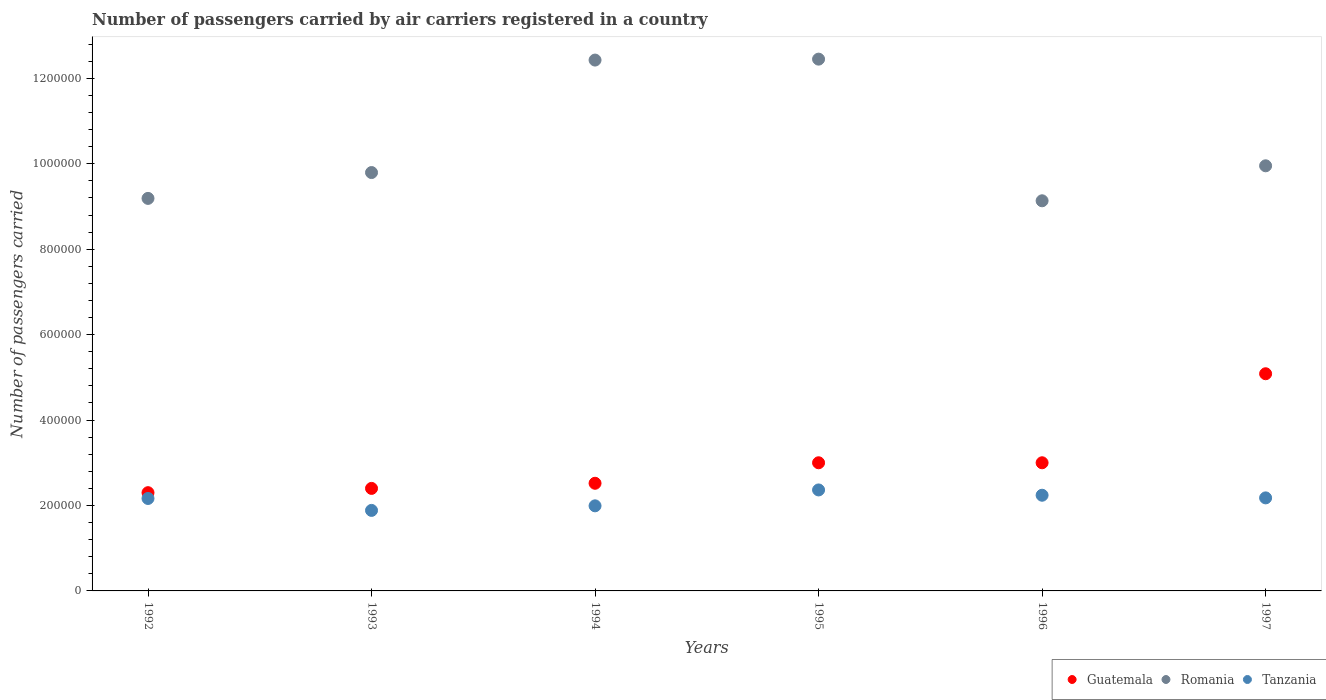How many different coloured dotlines are there?
Keep it short and to the point. 3. What is the number of passengers carried by air carriers in Tanzania in 1993?
Your response must be concise. 1.88e+05. Across all years, what is the maximum number of passengers carried by air carriers in Guatemala?
Your answer should be very brief. 5.08e+05. In which year was the number of passengers carried by air carriers in Romania maximum?
Your response must be concise. 1995. In which year was the number of passengers carried by air carriers in Romania minimum?
Offer a very short reply. 1996. What is the total number of passengers carried by air carriers in Romania in the graph?
Offer a terse response. 6.29e+06. What is the difference between the number of passengers carried by air carriers in Tanzania in 1992 and that in 1993?
Your response must be concise. 2.79e+04. What is the difference between the number of passengers carried by air carriers in Guatemala in 1992 and the number of passengers carried by air carriers in Tanzania in 1997?
Your response must be concise. 1.22e+04. What is the average number of passengers carried by air carriers in Guatemala per year?
Ensure brevity in your answer.  3.05e+05. In the year 1994, what is the difference between the number of passengers carried by air carriers in Romania and number of passengers carried by air carriers in Guatemala?
Ensure brevity in your answer.  9.91e+05. What is the ratio of the number of passengers carried by air carriers in Guatemala in 1995 to that in 1997?
Keep it short and to the point. 0.59. Is the difference between the number of passengers carried by air carriers in Romania in 1994 and 1995 greater than the difference between the number of passengers carried by air carriers in Guatemala in 1994 and 1995?
Keep it short and to the point. Yes. What is the difference between the highest and the second highest number of passengers carried by air carriers in Romania?
Offer a terse response. 2200. What is the difference between the highest and the lowest number of passengers carried by air carriers in Romania?
Offer a very short reply. 3.32e+05. In how many years, is the number of passengers carried by air carriers in Guatemala greater than the average number of passengers carried by air carriers in Guatemala taken over all years?
Offer a very short reply. 1. Is the sum of the number of passengers carried by air carriers in Guatemala in 1996 and 1997 greater than the maximum number of passengers carried by air carriers in Romania across all years?
Your response must be concise. No. Is the number of passengers carried by air carriers in Tanzania strictly greater than the number of passengers carried by air carriers in Romania over the years?
Provide a succinct answer. No. How many dotlines are there?
Your answer should be very brief. 3. What is the difference between two consecutive major ticks on the Y-axis?
Keep it short and to the point. 2.00e+05. Are the values on the major ticks of Y-axis written in scientific E-notation?
Your answer should be very brief. No. Does the graph contain any zero values?
Your response must be concise. No. Does the graph contain grids?
Your answer should be very brief. No. Where does the legend appear in the graph?
Your answer should be compact. Bottom right. How many legend labels are there?
Your answer should be very brief. 3. How are the legend labels stacked?
Your response must be concise. Horizontal. What is the title of the graph?
Your answer should be compact. Number of passengers carried by air carriers registered in a country. Does "South Sudan" appear as one of the legend labels in the graph?
Provide a succinct answer. No. What is the label or title of the X-axis?
Keep it short and to the point. Years. What is the label or title of the Y-axis?
Provide a short and direct response. Number of passengers carried. What is the Number of passengers carried of Guatemala in 1992?
Offer a terse response. 2.30e+05. What is the Number of passengers carried in Romania in 1992?
Ensure brevity in your answer.  9.19e+05. What is the Number of passengers carried in Tanzania in 1992?
Make the answer very short. 2.16e+05. What is the Number of passengers carried of Guatemala in 1993?
Offer a terse response. 2.40e+05. What is the Number of passengers carried of Romania in 1993?
Offer a very short reply. 9.79e+05. What is the Number of passengers carried of Tanzania in 1993?
Offer a terse response. 1.88e+05. What is the Number of passengers carried in Guatemala in 1994?
Provide a short and direct response. 2.52e+05. What is the Number of passengers carried in Romania in 1994?
Provide a short and direct response. 1.24e+06. What is the Number of passengers carried in Tanzania in 1994?
Give a very brief answer. 1.99e+05. What is the Number of passengers carried in Guatemala in 1995?
Your answer should be very brief. 3.00e+05. What is the Number of passengers carried in Romania in 1995?
Ensure brevity in your answer.  1.24e+06. What is the Number of passengers carried in Tanzania in 1995?
Make the answer very short. 2.36e+05. What is the Number of passengers carried of Romania in 1996?
Give a very brief answer. 9.13e+05. What is the Number of passengers carried in Tanzania in 1996?
Provide a succinct answer. 2.24e+05. What is the Number of passengers carried in Guatemala in 1997?
Your answer should be very brief. 5.08e+05. What is the Number of passengers carried in Romania in 1997?
Offer a terse response. 9.95e+05. What is the Number of passengers carried of Tanzania in 1997?
Make the answer very short. 2.18e+05. Across all years, what is the maximum Number of passengers carried in Guatemala?
Give a very brief answer. 5.08e+05. Across all years, what is the maximum Number of passengers carried of Romania?
Provide a succinct answer. 1.24e+06. Across all years, what is the maximum Number of passengers carried of Tanzania?
Your answer should be very brief. 2.36e+05. Across all years, what is the minimum Number of passengers carried in Guatemala?
Your answer should be compact. 2.30e+05. Across all years, what is the minimum Number of passengers carried of Romania?
Keep it short and to the point. 9.13e+05. Across all years, what is the minimum Number of passengers carried in Tanzania?
Offer a very short reply. 1.88e+05. What is the total Number of passengers carried in Guatemala in the graph?
Your answer should be very brief. 1.83e+06. What is the total Number of passengers carried of Romania in the graph?
Your answer should be compact. 6.29e+06. What is the total Number of passengers carried in Tanzania in the graph?
Provide a short and direct response. 1.28e+06. What is the difference between the Number of passengers carried of Romania in 1992 and that in 1993?
Offer a very short reply. -6.05e+04. What is the difference between the Number of passengers carried in Tanzania in 1992 and that in 1993?
Provide a short and direct response. 2.79e+04. What is the difference between the Number of passengers carried in Guatemala in 1992 and that in 1994?
Provide a short and direct response. -2.20e+04. What is the difference between the Number of passengers carried of Romania in 1992 and that in 1994?
Make the answer very short. -3.24e+05. What is the difference between the Number of passengers carried of Tanzania in 1992 and that in 1994?
Provide a short and direct response. 1.72e+04. What is the difference between the Number of passengers carried of Guatemala in 1992 and that in 1995?
Provide a short and direct response. -7.00e+04. What is the difference between the Number of passengers carried of Romania in 1992 and that in 1995?
Provide a short and direct response. -3.26e+05. What is the difference between the Number of passengers carried of Guatemala in 1992 and that in 1996?
Your response must be concise. -7.00e+04. What is the difference between the Number of passengers carried of Romania in 1992 and that in 1996?
Offer a very short reply. 5600. What is the difference between the Number of passengers carried in Tanzania in 1992 and that in 1996?
Provide a succinct answer. -7600. What is the difference between the Number of passengers carried of Guatemala in 1992 and that in 1997?
Provide a short and direct response. -2.78e+05. What is the difference between the Number of passengers carried of Romania in 1992 and that in 1997?
Provide a short and direct response. -7.63e+04. What is the difference between the Number of passengers carried of Tanzania in 1992 and that in 1997?
Provide a succinct answer. -1400. What is the difference between the Number of passengers carried in Guatemala in 1993 and that in 1994?
Give a very brief answer. -1.20e+04. What is the difference between the Number of passengers carried in Romania in 1993 and that in 1994?
Your answer should be compact. -2.63e+05. What is the difference between the Number of passengers carried of Tanzania in 1993 and that in 1994?
Your response must be concise. -1.07e+04. What is the difference between the Number of passengers carried of Guatemala in 1993 and that in 1995?
Make the answer very short. -6.00e+04. What is the difference between the Number of passengers carried in Romania in 1993 and that in 1995?
Make the answer very short. -2.66e+05. What is the difference between the Number of passengers carried of Tanzania in 1993 and that in 1995?
Offer a very short reply. -4.79e+04. What is the difference between the Number of passengers carried in Romania in 1993 and that in 1996?
Provide a succinct answer. 6.61e+04. What is the difference between the Number of passengers carried of Tanzania in 1993 and that in 1996?
Offer a very short reply. -3.55e+04. What is the difference between the Number of passengers carried in Guatemala in 1993 and that in 1997?
Your answer should be compact. -2.68e+05. What is the difference between the Number of passengers carried in Romania in 1993 and that in 1997?
Provide a short and direct response. -1.58e+04. What is the difference between the Number of passengers carried of Tanzania in 1993 and that in 1997?
Offer a very short reply. -2.93e+04. What is the difference between the Number of passengers carried of Guatemala in 1994 and that in 1995?
Give a very brief answer. -4.80e+04. What is the difference between the Number of passengers carried of Romania in 1994 and that in 1995?
Provide a succinct answer. -2200. What is the difference between the Number of passengers carried of Tanzania in 1994 and that in 1995?
Provide a short and direct response. -3.72e+04. What is the difference between the Number of passengers carried in Guatemala in 1994 and that in 1996?
Your answer should be compact. -4.80e+04. What is the difference between the Number of passengers carried of Romania in 1994 and that in 1996?
Offer a terse response. 3.29e+05. What is the difference between the Number of passengers carried of Tanzania in 1994 and that in 1996?
Offer a very short reply. -2.48e+04. What is the difference between the Number of passengers carried in Guatemala in 1994 and that in 1997?
Offer a very short reply. -2.56e+05. What is the difference between the Number of passengers carried of Romania in 1994 and that in 1997?
Provide a succinct answer. 2.48e+05. What is the difference between the Number of passengers carried of Tanzania in 1994 and that in 1997?
Offer a terse response. -1.86e+04. What is the difference between the Number of passengers carried of Guatemala in 1995 and that in 1996?
Ensure brevity in your answer.  0. What is the difference between the Number of passengers carried in Romania in 1995 and that in 1996?
Your response must be concise. 3.32e+05. What is the difference between the Number of passengers carried of Tanzania in 1995 and that in 1996?
Your answer should be compact. 1.24e+04. What is the difference between the Number of passengers carried of Guatemala in 1995 and that in 1997?
Make the answer very short. -2.08e+05. What is the difference between the Number of passengers carried in Romania in 1995 and that in 1997?
Keep it short and to the point. 2.50e+05. What is the difference between the Number of passengers carried in Tanzania in 1995 and that in 1997?
Offer a very short reply. 1.86e+04. What is the difference between the Number of passengers carried in Guatemala in 1996 and that in 1997?
Your answer should be very brief. -2.08e+05. What is the difference between the Number of passengers carried in Romania in 1996 and that in 1997?
Your answer should be very brief. -8.19e+04. What is the difference between the Number of passengers carried in Tanzania in 1996 and that in 1997?
Your answer should be very brief. 6200. What is the difference between the Number of passengers carried of Guatemala in 1992 and the Number of passengers carried of Romania in 1993?
Your answer should be compact. -7.49e+05. What is the difference between the Number of passengers carried in Guatemala in 1992 and the Number of passengers carried in Tanzania in 1993?
Your answer should be very brief. 4.15e+04. What is the difference between the Number of passengers carried in Romania in 1992 and the Number of passengers carried in Tanzania in 1993?
Provide a succinct answer. 7.30e+05. What is the difference between the Number of passengers carried of Guatemala in 1992 and the Number of passengers carried of Romania in 1994?
Give a very brief answer. -1.01e+06. What is the difference between the Number of passengers carried of Guatemala in 1992 and the Number of passengers carried of Tanzania in 1994?
Your answer should be very brief. 3.08e+04. What is the difference between the Number of passengers carried in Romania in 1992 and the Number of passengers carried in Tanzania in 1994?
Offer a terse response. 7.20e+05. What is the difference between the Number of passengers carried in Guatemala in 1992 and the Number of passengers carried in Romania in 1995?
Offer a very short reply. -1.01e+06. What is the difference between the Number of passengers carried in Guatemala in 1992 and the Number of passengers carried in Tanzania in 1995?
Offer a very short reply. -6400. What is the difference between the Number of passengers carried of Romania in 1992 and the Number of passengers carried of Tanzania in 1995?
Give a very brief answer. 6.82e+05. What is the difference between the Number of passengers carried of Guatemala in 1992 and the Number of passengers carried of Romania in 1996?
Your answer should be compact. -6.83e+05. What is the difference between the Number of passengers carried in Guatemala in 1992 and the Number of passengers carried in Tanzania in 1996?
Provide a succinct answer. 6000. What is the difference between the Number of passengers carried in Romania in 1992 and the Number of passengers carried in Tanzania in 1996?
Your answer should be very brief. 6.95e+05. What is the difference between the Number of passengers carried in Guatemala in 1992 and the Number of passengers carried in Romania in 1997?
Give a very brief answer. -7.65e+05. What is the difference between the Number of passengers carried in Guatemala in 1992 and the Number of passengers carried in Tanzania in 1997?
Ensure brevity in your answer.  1.22e+04. What is the difference between the Number of passengers carried of Romania in 1992 and the Number of passengers carried of Tanzania in 1997?
Your answer should be compact. 7.01e+05. What is the difference between the Number of passengers carried in Guatemala in 1993 and the Number of passengers carried in Romania in 1994?
Your answer should be very brief. -1.00e+06. What is the difference between the Number of passengers carried of Guatemala in 1993 and the Number of passengers carried of Tanzania in 1994?
Offer a very short reply. 4.08e+04. What is the difference between the Number of passengers carried of Romania in 1993 and the Number of passengers carried of Tanzania in 1994?
Your answer should be very brief. 7.80e+05. What is the difference between the Number of passengers carried of Guatemala in 1993 and the Number of passengers carried of Romania in 1995?
Provide a succinct answer. -1.00e+06. What is the difference between the Number of passengers carried in Guatemala in 1993 and the Number of passengers carried in Tanzania in 1995?
Offer a very short reply. 3600. What is the difference between the Number of passengers carried in Romania in 1993 and the Number of passengers carried in Tanzania in 1995?
Your response must be concise. 7.43e+05. What is the difference between the Number of passengers carried of Guatemala in 1993 and the Number of passengers carried of Romania in 1996?
Give a very brief answer. -6.73e+05. What is the difference between the Number of passengers carried of Guatemala in 1993 and the Number of passengers carried of Tanzania in 1996?
Keep it short and to the point. 1.60e+04. What is the difference between the Number of passengers carried in Romania in 1993 and the Number of passengers carried in Tanzania in 1996?
Give a very brief answer. 7.55e+05. What is the difference between the Number of passengers carried of Guatemala in 1993 and the Number of passengers carried of Romania in 1997?
Your answer should be compact. -7.55e+05. What is the difference between the Number of passengers carried in Guatemala in 1993 and the Number of passengers carried in Tanzania in 1997?
Offer a very short reply. 2.22e+04. What is the difference between the Number of passengers carried in Romania in 1993 and the Number of passengers carried in Tanzania in 1997?
Your answer should be very brief. 7.62e+05. What is the difference between the Number of passengers carried in Guatemala in 1994 and the Number of passengers carried in Romania in 1995?
Provide a succinct answer. -9.93e+05. What is the difference between the Number of passengers carried in Guatemala in 1994 and the Number of passengers carried in Tanzania in 1995?
Ensure brevity in your answer.  1.56e+04. What is the difference between the Number of passengers carried in Romania in 1994 and the Number of passengers carried in Tanzania in 1995?
Offer a terse response. 1.01e+06. What is the difference between the Number of passengers carried of Guatemala in 1994 and the Number of passengers carried of Romania in 1996?
Keep it short and to the point. -6.61e+05. What is the difference between the Number of passengers carried of Guatemala in 1994 and the Number of passengers carried of Tanzania in 1996?
Your response must be concise. 2.80e+04. What is the difference between the Number of passengers carried in Romania in 1994 and the Number of passengers carried in Tanzania in 1996?
Ensure brevity in your answer.  1.02e+06. What is the difference between the Number of passengers carried of Guatemala in 1994 and the Number of passengers carried of Romania in 1997?
Provide a short and direct response. -7.43e+05. What is the difference between the Number of passengers carried in Guatemala in 1994 and the Number of passengers carried in Tanzania in 1997?
Provide a short and direct response. 3.42e+04. What is the difference between the Number of passengers carried in Romania in 1994 and the Number of passengers carried in Tanzania in 1997?
Make the answer very short. 1.02e+06. What is the difference between the Number of passengers carried in Guatemala in 1995 and the Number of passengers carried in Romania in 1996?
Make the answer very short. -6.13e+05. What is the difference between the Number of passengers carried of Guatemala in 1995 and the Number of passengers carried of Tanzania in 1996?
Provide a short and direct response. 7.60e+04. What is the difference between the Number of passengers carried in Romania in 1995 and the Number of passengers carried in Tanzania in 1996?
Your answer should be very brief. 1.02e+06. What is the difference between the Number of passengers carried of Guatemala in 1995 and the Number of passengers carried of Romania in 1997?
Ensure brevity in your answer.  -6.95e+05. What is the difference between the Number of passengers carried of Guatemala in 1995 and the Number of passengers carried of Tanzania in 1997?
Give a very brief answer. 8.22e+04. What is the difference between the Number of passengers carried of Romania in 1995 and the Number of passengers carried of Tanzania in 1997?
Ensure brevity in your answer.  1.03e+06. What is the difference between the Number of passengers carried of Guatemala in 1996 and the Number of passengers carried of Romania in 1997?
Offer a very short reply. -6.95e+05. What is the difference between the Number of passengers carried in Guatemala in 1996 and the Number of passengers carried in Tanzania in 1997?
Your answer should be very brief. 8.22e+04. What is the difference between the Number of passengers carried in Romania in 1996 and the Number of passengers carried in Tanzania in 1997?
Provide a short and direct response. 6.96e+05. What is the average Number of passengers carried in Guatemala per year?
Give a very brief answer. 3.05e+05. What is the average Number of passengers carried in Romania per year?
Keep it short and to the point. 1.05e+06. What is the average Number of passengers carried of Tanzania per year?
Give a very brief answer. 2.14e+05. In the year 1992, what is the difference between the Number of passengers carried in Guatemala and Number of passengers carried in Romania?
Provide a succinct answer. -6.89e+05. In the year 1992, what is the difference between the Number of passengers carried in Guatemala and Number of passengers carried in Tanzania?
Provide a succinct answer. 1.36e+04. In the year 1992, what is the difference between the Number of passengers carried of Romania and Number of passengers carried of Tanzania?
Give a very brief answer. 7.02e+05. In the year 1993, what is the difference between the Number of passengers carried of Guatemala and Number of passengers carried of Romania?
Keep it short and to the point. -7.39e+05. In the year 1993, what is the difference between the Number of passengers carried of Guatemala and Number of passengers carried of Tanzania?
Provide a short and direct response. 5.15e+04. In the year 1993, what is the difference between the Number of passengers carried of Romania and Number of passengers carried of Tanzania?
Offer a terse response. 7.91e+05. In the year 1994, what is the difference between the Number of passengers carried of Guatemala and Number of passengers carried of Romania?
Offer a very short reply. -9.91e+05. In the year 1994, what is the difference between the Number of passengers carried in Guatemala and Number of passengers carried in Tanzania?
Offer a very short reply. 5.28e+04. In the year 1994, what is the difference between the Number of passengers carried in Romania and Number of passengers carried in Tanzania?
Your response must be concise. 1.04e+06. In the year 1995, what is the difference between the Number of passengers carried of Guatemala and Number of passengers carried of Romania?
Offer a terse response. -9.45e+05. In the year 1995, what is the difference between the Number of passengers carried of Guatemala and Number of passengers carried of Tanzania?
Provide a succinct answer. 6.36e+04. In the year 1995, what is the difference between the Number of passengers carried of Romania and Number of passengers carried of Tanzania?
Your response must be concise. 1.01e+06. In the year 1996, what is the difference between the Number of passengers carried in Guatemala and Number of passengers carried in Romania?
Ensure brevity in your answer.  -6.13e+05. In the year 1996, what is the difference between the Number of passengers carried of Guatemala and Number of passengers carried of Tanzania?
Make the answer very short. 7.60e+04. In the year 1996, what is the difference between the Number of passengers carried in Romania and Number of passengers carried in Tanzania?
Make the answer very short. 6.89e+05. In the year 1997, what is the difference between the Number of passengers carried in Guatemala and Number of passengers carried in Romania?
Give a very brief answer. -4.87e+05. In the year 1997, what is the difference between the Number of passengers carried of Guatemala and Number of passengers carried of Tanzania?
Give a very brief answer. 2.91e+05. In the year 1997, what is the difference between the Number of passengers carried of Romania and Number of passengers carried of Tanzania?
Your response must be concise. 7.77e+05. What is the ratio of the Number of passengers carried of Guatemala in 1992 to that in 1993?
Offer a very short reply. 0.96. What is the ratio of the Number of passengers carried in Romania in 1992 to that in 1993?
Make the answer very short. 0.94. What is the ratio of the Number of passengers carried of Tanzania in 1992 to that in 1993?
Offer a terse response. 1.15. What is the ratio of the Number of passengers carried in Guatemala in 1992 to that in 1994?
Offer a very short reply. 0.91. What is the ratio of the Number of passengers carried of Romania in 1992 to that in 1994?
Your response must be concise. 0.74. What is the ratio of the Number of passengers carried in Tanzania in 1992 to that in 1994?
Keep it short and to the point. 1.09. What is the ratio of the Number of passengers carried in Guatemala in 1992 to that in 1995?
Ensure brevity in your answer.  0.77. What is the ratio of the Number of passengers carried of Romania in 1992 to that in 1995?
Provide a succinct answer. 0.74. What is the ratio of the Number of passengers carried in Tanzania in 1992 to that in 1995?
Provide a short and direct response. 0.92. What is the ratio of the Number of passengers carried of Guatemala in 1992 to that in 1996?
Your answer should be compact. 0.77. What is the ratio of the Number of passengers carried in Romania in 1992 to that in 1996?
Make the answer very short. 1.01. What is the ratio of the Number of passengers carried in Tanzania in 1992 to that in 1996?
Ensure brevity in your answer.  0.97. What is the ratio of the Number of passengers carried in Guatemala in 1992 to that in 1997?
Keep it short and to the point. 0.45. What is the ratio of the Number of passengers carried of Romania in 1992 to that in 1997?
Keep it short and to the point. 0.92. What is the ratio of the Number of passengers carried in Romania in 1993 to that in 1994?
Your answer should be very brief. 0.79. What is the ratio of the Number of passengers carried of Tanzania in 1993 to that in 1994?
Provide a succinct answer. 0.95. What is the ratio of the Number of passengers carried of Guatemala in 1993 to that in 1995?
Your response must be concise. 0.8. What is the ratio of the Number of passengers carried in Romania in 1993 to that in 1995?
Keep it short and to the point. 0.79. What is the ratio of the Number of passengers carried in Tanzania in 1993 to that in 1995?
Offer a very short reply. 0.8. What is the ratio of the Number of passengers carried in Romania in 1993 to that in 1996?
Offer a terse response. 1.07. What is the ratio of the Number of passengers carried in Tanzania in 1993 to that in 1996?
Your answer should be very brief. 0.84. What is the ratio of the Number of passengers carried of Guatemala in 1993 to that in 1997?
Your answer should be very brief. 0.47. What is the ratio of the Number of passengers carried in Romania in 1993 to that in 1997?
Provide a succinct answer. 0.98. What is the ratio of the Number of passengers carried of Tanzania in 1993 to that in 1997?
Keep it short and to the point. 0.87. What is the ratio of the Number of passengers carried in Guatemala in 1994 to that in 1995?
Your response must be concise. 0.84. What is the ratio of the Number of passengers carried in Romania in 1994 to that in 1995?
Make the answer very short. 1. What is the ratio of the Number of passengers carried in Tanzania in 1994 to that in 1995?
Offer a terse response. 0.84. What is the ratio of the Number of passengers carried in Guatemala in 1994 to that in 1996?
Provide a short and direct response. 0.84. What is the ratio of the Number of passengers carried in Romania in 1994 to that in 1996?
Your response must be concise. 1.36. What is the ratio of the Number of passengers carried in Tanzania in 1994 to that in 1996?
Your answer should be very brief. 0.89. What is the ratio of the Number of passengers carried of Guatemala in 1994 to that in 1997?
Ensure brevity in your answer.  0.5. What is the ratio of the Number of passengers carried in Romania in 1994 to that in 1997?
Your response must be concise. 1.25. What is the ratio of the Number of passengers carried in Tanzania in 1994 to that in 1997?
Offer a terse response. 0.91. What is the ratio of the Number of passengers carried of Romania in 1995 to that in 1996?
Give a very brief answer. 1.36. What is the ratio of the Number of passengers carried in Tanzania in 1995 to that in 1996?
Ensure brevity in your answer.  1.06. What is the ratio of the Number of passengers carried in Guatemala in 1995 to that in 1997?
Keep it short and to the point. 0.59. What is the ratio of the Number of passengers carried in Romania in 1995 to that in 1997?
Offer a very short reply. 1.25. What is the ratio of the Number of passengers carried of Tanzania in 1995 to that in 1997?
Provide a succinct answer. 1.09. What is the ratio of the Number of passengers carried of Guatemala in 1996 to that in 1997?
Make the answer very short. 0.59. What is the ratio of the Number of passengers carried in Romania in 1996 to that in 1997?
Keep it short and to the point. 0.92. What is the ratio of the Number of passengers carried in Tanzania in 1996 to that in 1997?
Offer a very short reply. 1.03. What is the difference between the highest and the second highest Number of passengers carried in Guatemala?
Keep it short and to the point. 2.08e+05. What is the difference between the highest and the second highest Number of passengers carried of Romania?
Provide a succinct answer. 2200. What is the difference between the highest and the second highest Number of passengers carried of Tanzania?
Give a very brief answer. 1.24e+04. What is the difference between the highest and the lowest Number of passengers carried of Guatemala?
Make the answer very short. 2.78e+05. What is the difference between the highest and the lowest Number of passengers carried in Romania?
Ensure brevity in your answer.  3.32e+05. What is the difference between the highest and the lowest Number of passengers carried of Tanzania?
Ensure brevity in your answer.  4.79e+04. 